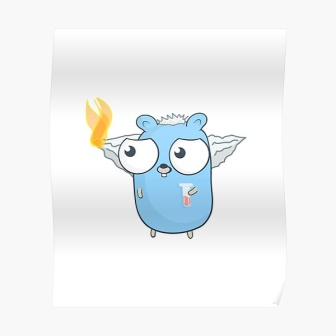Describe the setting where you think this creature exists. I envision this blue, whimsical creature inhabiting a magical forest filled with towering, ancient trees. The forest is bathed in soft, dappled sunlight filtering through the thick canopy, casting enchanting patterns on the forest floor. Colorful flora and fauna abound, with flowers that glow softly and leaves that shimmer in the breeze. In the heart of the forest lies a sparkling, crystal-clear stream where the creature can often be seen playfully interacting with other fantastical beings. The serene, yet mystical atmosphere of the forest perfectly complements the creature’s unique and magical qualities. Why does the creature have a flame on its head? The flame atop the creature’s head is believed to be a symbol of its magical power and inner spirit. It is said that the flame’s brightness reflects the creature’s emotions and energy levels. On days when the creature is particularly joyful or engaged in something it loves, the flame burns brightly and warmly. Conversely, it may dim or flicker gently when the creature is calm or contemplative. The flame serves not only as an emotive expression but also as a beacon for other creatures in the forest, guiding them towards moments of joy and wonder. Could this creature be part of a story? Absolutely! This whimsical creature would make a perfect protagonist in a magical adventure story. Imagine a tale where it embarks on a journey to save its enchanted forest from an impending shadow that threatens to engulf it. Along the way, it encounters a diverse cast of characters, each with their own unique abilities and stories. The creature’s flame acts as a guiding light, metaphorically representing hope and unity. Together, they unravel mysteries, overcome obstacles, and learn the profound truths about friendship, courage, and the magic that lies within. 